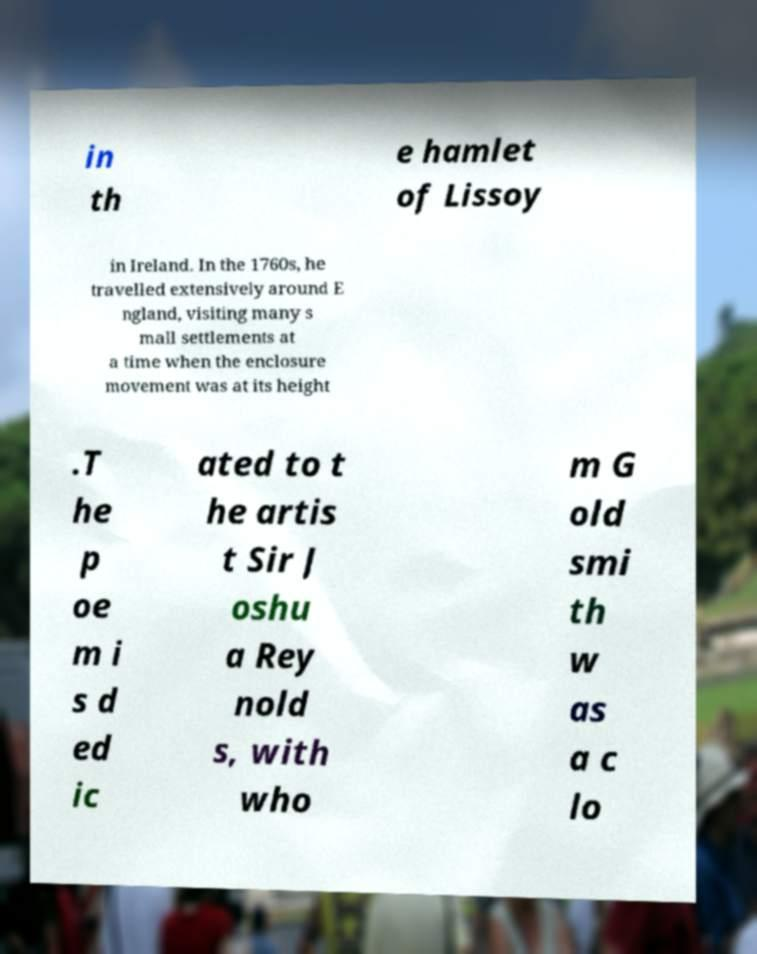Could you assist in decoding the text presented in this image and type it out clearly? in th e hamlet of Lissoy in Ireland. In the 1760s, he travelled extensively around E ngland, visiting many s mall settlements at a time when the enclosure movement was at its height .T he p oe m i s d ed ic ated to t he artis t Sir J oshu a Rey nold s, with who m G old smi th w as a c lo 